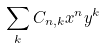Convert formula to latex. <formula><loc_0><loc_0><loc_500><loc_500>\sum _ { k } C _ { n , k } x ^ { n } y ^ { k }</formula> 